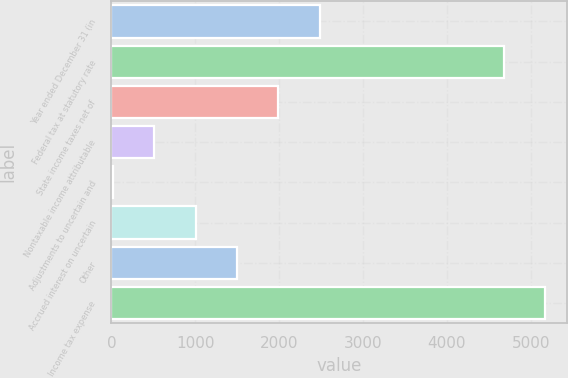Convert chart. <chart><loc_0><loc_0><loc_500><loc_500><bar_chart><fcel>Year ended December 31 (in<fcel>Federal tax at statutory rate<fcel>State income taxes net of<fcel>Nontaxable income attributable<fcel>Adjustments to uncertain and<fcel>Accrued interest on uncertain<fcel>Other<fcel>Income tax expense<nl><fcel>2487<fcel>4680<fcel>1992.6<fcel>509.4<fcel>15<fcel>1003.8<fcel>1498.2<fcel>5174.4<nl></chart> 